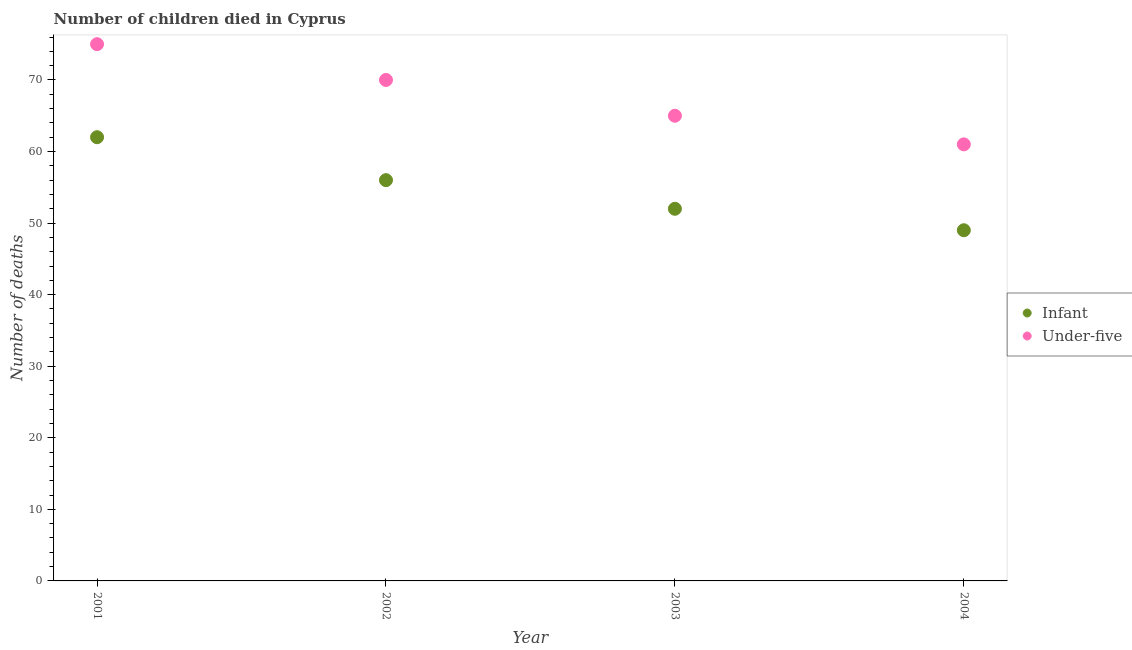How many different coloured dotlines are there?
Ensure brevity in your answer.  2. Is the number of dotlines equal to the number of legend labels?
Your answer should be very brief. Yes. What is the number of under-five deaths in 2003?
Your answer should be very brief. 65. Across all years, what is the maximum number of under-five deaths?
Offer a terse response. 75. Across all years, what is the minimum number of infant deaths?
Your answer should be very brief. 49. In which year was the number of infant deaths minimum?
Offer a very short reply. 2004. What is the total number of under-five deaths in the graph?
Offer a very short reply. 271. What is the difference between the number of infant deaths in 2001 and that in 2003?
Provide a succinct answer. 10. What is the difference between the number of infant deaths in 2003 and the number of under-five deaths in 2002?
Your response must be concise. -18. What is the average number of infant deaths per year?
Your response must be concise. 54.75. In the year 2003, what is the difference between the number of infant deaths and number of under-five deaths?
Your answer should be compact. -13. In how many years, is the number of under-five deaths greater than 68?
Provide a succinct answer. 2. What is the ratio of the number of infant deaths in 2001 to that in 2004?
Your answer should be compact. 1.27. Is the number of under-five deaths in 2001 less than that in 2004?
Your answer should be very brief. No. What is the difference between the highest and the lowest number of under-five deaths?
Provide a succinct answer. 14. Is the sum of the number of under-five deaths in 2001 and 2003 greater than the maximum number of infant deaths across all years?
Provide a succinct answer. Yes. Is the number of infant deaths strictly less than the number of under-five deaths over the years?
Offer a very short reply. Yes. How many dotlines are there?
Your answer should be very brief. 2. Are the values on the major ticks of Y-axis written in scientific E-notation?
Make the answer very short. No. Where does the legend appear in the graph?
Offer a terse response. Center right. What is the title of the graph?
Your answer should be compact. Number of children died in Cyprus. What is the label or title of the Y-axis?
Your response must be concise. Number of deaths. What is the Number of deaths of Under-five in 2001?
Keep it short and to the point. 75. What is the Number of deaths of Infant in 2002?
Offer a terse response. 56. What is the Number of deaths in Under-five in 2002?
Give a very brief answer. 70. What is the Number of deaths of Under-five in 2003?
Provide a succinct answer. 65. What is the Number of deaths of Under-five in 2004?
Your answer should be very brief. 61. Across all years, what is the maximum Number of deaths in Infant?
Your answer should be very brief. 62. Across all years, what is the maximum Number of deaths of Under-five?
Make the answer very short. 75. Across all years, what is the minimum Number of deaths of Infant?
Offer a terse response. 49. What is the total Number of deaths in Infant in the graph?
Offer a very short reply. 219. What is the total Number of deaths in Under-five in the graph?
Provide a short and direct response. 271. What is the difference between the Number of deaths of Under-five in 2001 and that in 2002?
Your answer should be compact. 5. What is the difference between the Number of deaths of Infant in 2001 and that in 2003?
Your answer should be compact. 10. What is the difference between the Number of deaths of Under-five in 2001 and that in 2004?
Offer a very short reply. 14. What is the difference between the Number of deaths in Infant in 2002 and that in 2003?
Make the answer very short. 4. What is the difference between the Number of deaths in Under-five in 2002 and that in 2003?
Make the answer very short. 5. What is the difference between the Number of deaths in Infant in 2001 and the Number of deaths in Under-five in 2002?
Offer a very short reply. -8. What is the difference between the Number of deaths in Infant in 2001 and the Number of deaths in Under-five in 2003?
Your answer should be compact. -3. What is the difference between the Number of deaths in Infant in 2002 and the Number of deaths in Under-five in 2004?
Ensure brevity in your answer.  -5. What is the difference between the Number of deaths in Infant in 2003 and the Number of deaths in Under-five in 2004?
Your response must be concise. -9. What is the average Number of deaths in Infant per year?
Provide a succinct answer. 54.75. What is the average Number of deaths in Under-five per year?
Provide a short and direct response. 67.75. In the year 2003, what is the difference between the Number of deaths of Infant and Number of deaths of Under-five?
Your answer should be very brief. -13. What is the ratio of the Number of deaths of Infant in 2001 to that in 2002?
Make the answer very short. 1.11. What is the ratio of the Number of deaths in Under-five in 2001 to that in 2002?
Provide a succinct answer. 1.07. What is the ratio of the Number of deaths of Infant in 2001 to that in 2003?
Keep it short and to the point. 1.19. What is the ratio of the Number of deaths of Under-five in 2001 to that in 2003?
Ensure brevity in your answer.  1.15. What is the ratio of the Number of deaths in Infant in 2001 to that in 2004?
Keep it short and to the point. 1.27. What is the ratio of the Number of deaths of Under-five in 2001 to that in 2004?
Make the answer very short. 1.23. What is the ratio of the Number of deaths in Infant in 2002 to that in 2003?
Offer a very short reply. 1.08. What is the ratio of the Number of deaths in Under-five in 2002 to that in 2004?
Provide a short and direct response. 1.15. What is the ratio of the Number of deaths in Infant in 2003 to that in 2004?
Offer a very short reply. 1.06. What is the ratio of the Number of deaths of Under-five in 2003 to that in 2004?
Give a very brief answer. 1.07. What is the difference between the highest and the lowest Number of deaths in Under-five?
Make the answer very short. 14. 